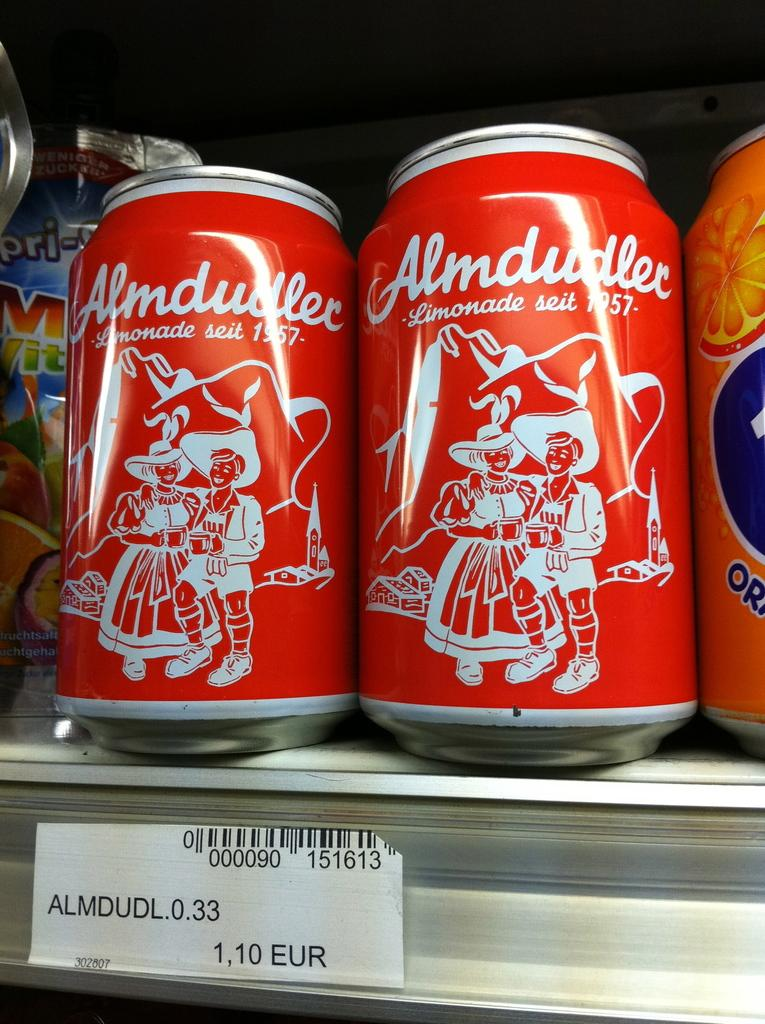Provide a one-sentence caption for the provided image. Two cans of Almdudler are sitting between fruit drinks on a store shelf. 